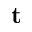<formula> <loc_0><loc_0><loc_500><loc_500>t</formula> 